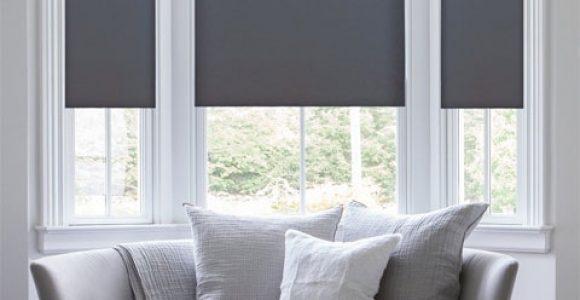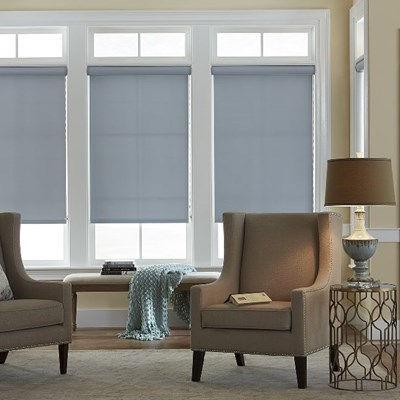The first image is the image on the left, the second image is the image on the right. Examine the images to the left and right. Is the description "There are exactly three window shades." accurate? Answer yes or no. No. The first image is the image on the left, the second image is the image on the right. Considering the images on both sides, is "The left and right image contains a total of three blinds." valid? Answer yes or no. No. 